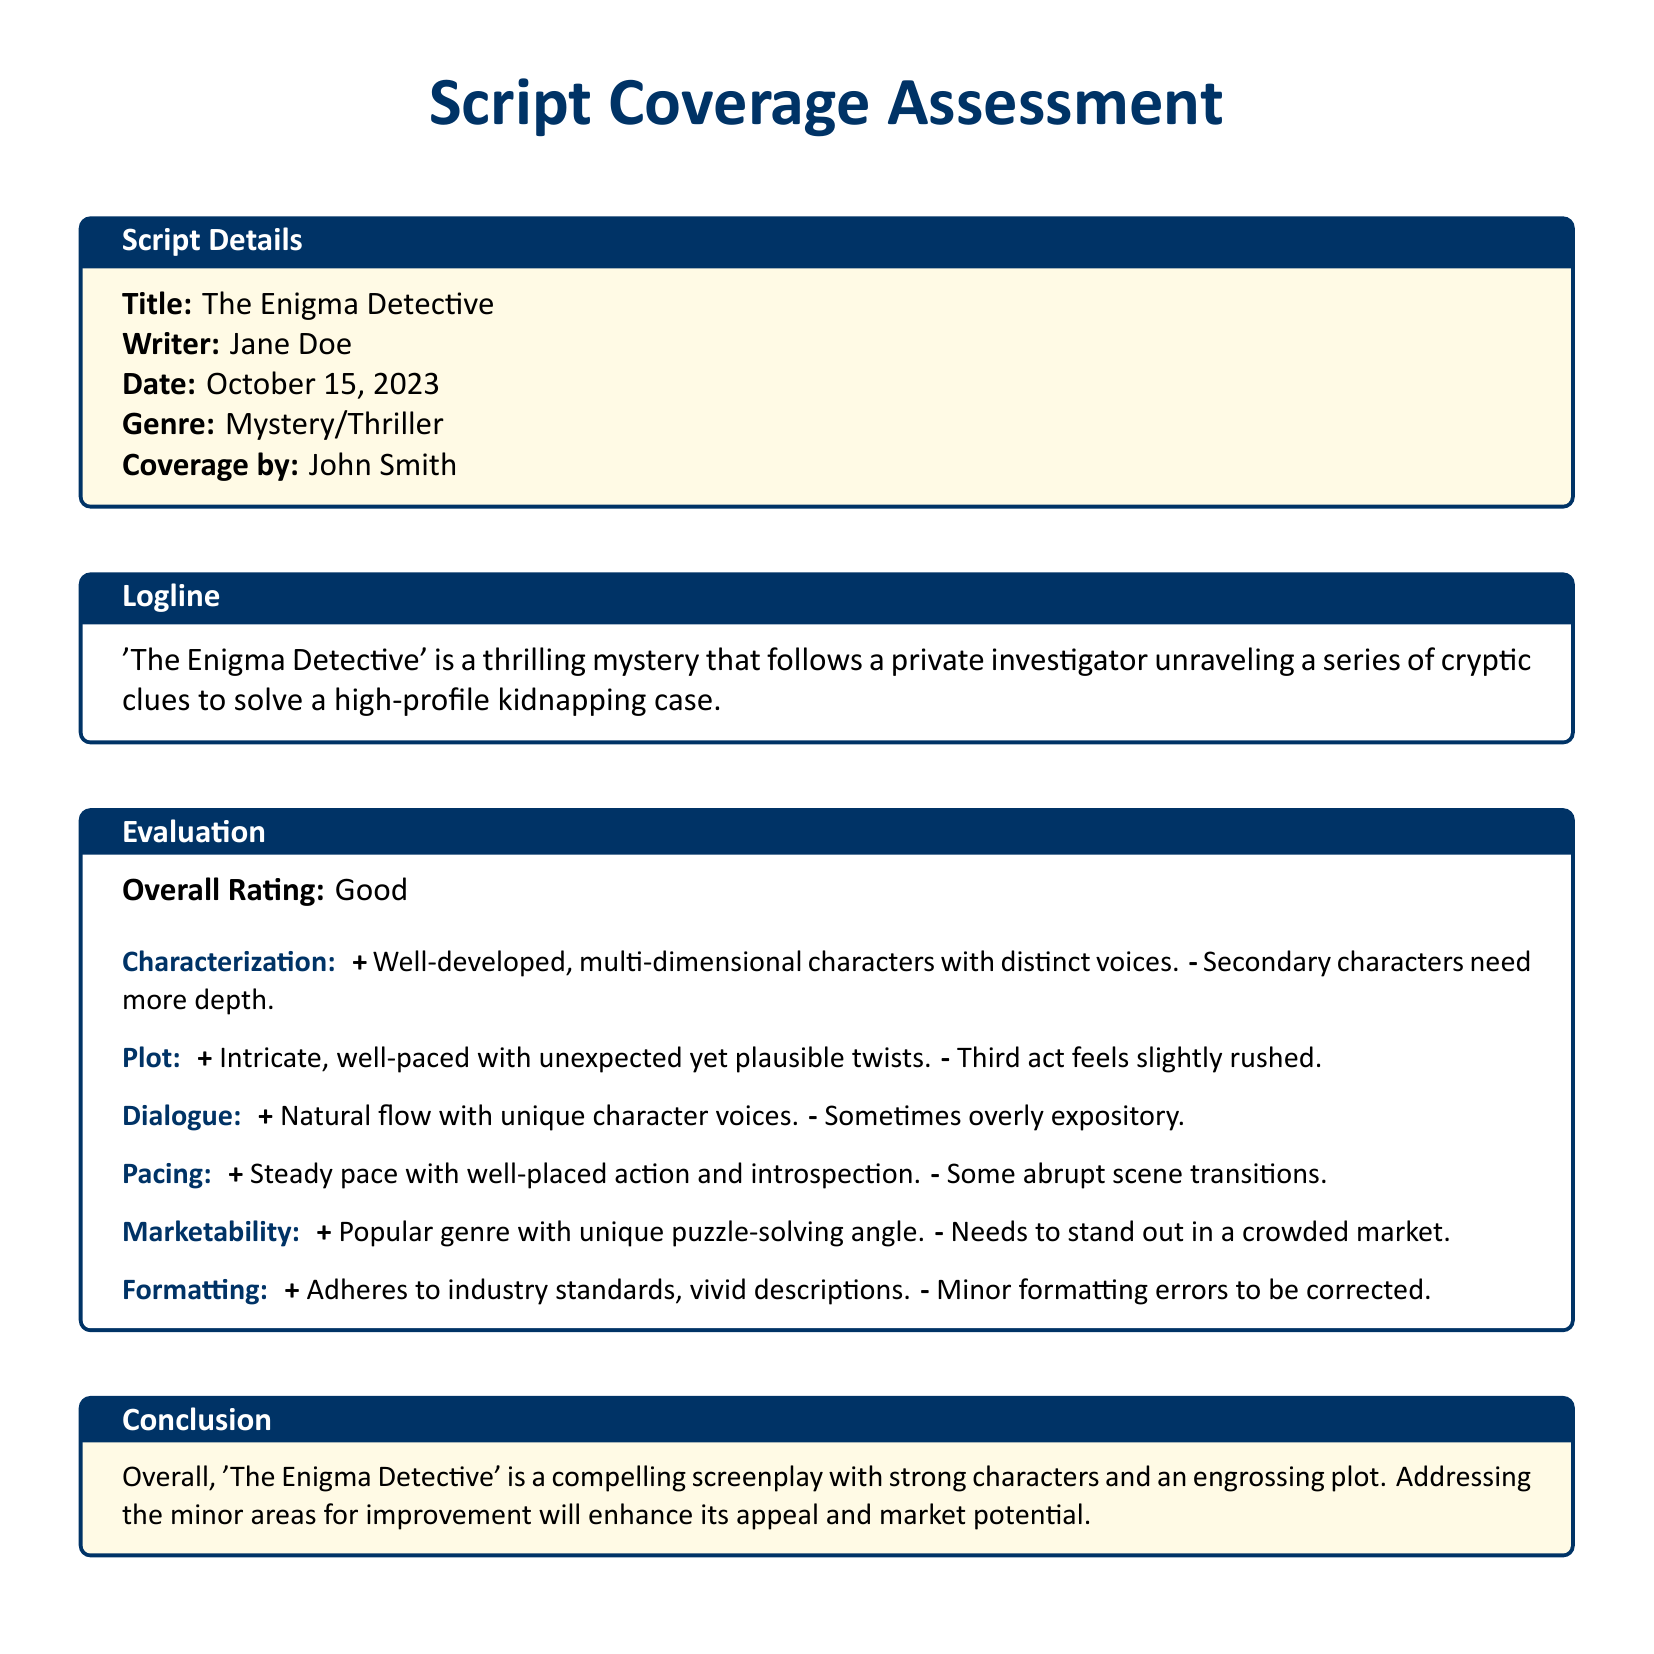what is the title of the screenplay? The title is explicitly mentioned in the "Script Details" section of the document.
Answer: The Enigma Detective who is the writer of the screenplay? The writer's name is provided in the "Script Details" section.
Answer: Jane Doe what is the overall rating given for the screenplay? The overall rating is clearly stated in the "Evaluation" section.
Answer: Good which character aspect needs improvement? The document specifies areas for improvement in characterization within the "Evaluation" section.
Answer: Secondary characters need more depth what genre does the screenplay belong to? The genre is indicated in the "Script Details" section.
Answer: Mystery/Thriller what is the conclusion about the screenplay? The conclusion offers a summation of the overall assessment found in the "Conclusion" section.
Answer: Compelling screenplay with strong characters what specific area of the plot feels rushed? The document highlights areas that feel rushed in the plot evaluation.
Answer: Third act what is a positive aspect of the dialogue? A positive aspect of dialogue is provided under the evaluation criteria in the document.
Answer: Natural flow with unique character voices what does the screenplay need to stand out? The marketability section indicates specific requirements for the screenplay to be more appealing.
Answer: Needs to stand out in a crowded market what date was the script coverage assessment conducted? The date is explicitly mentioned in the "Script Details" section.
Answer: October 15, 2023 